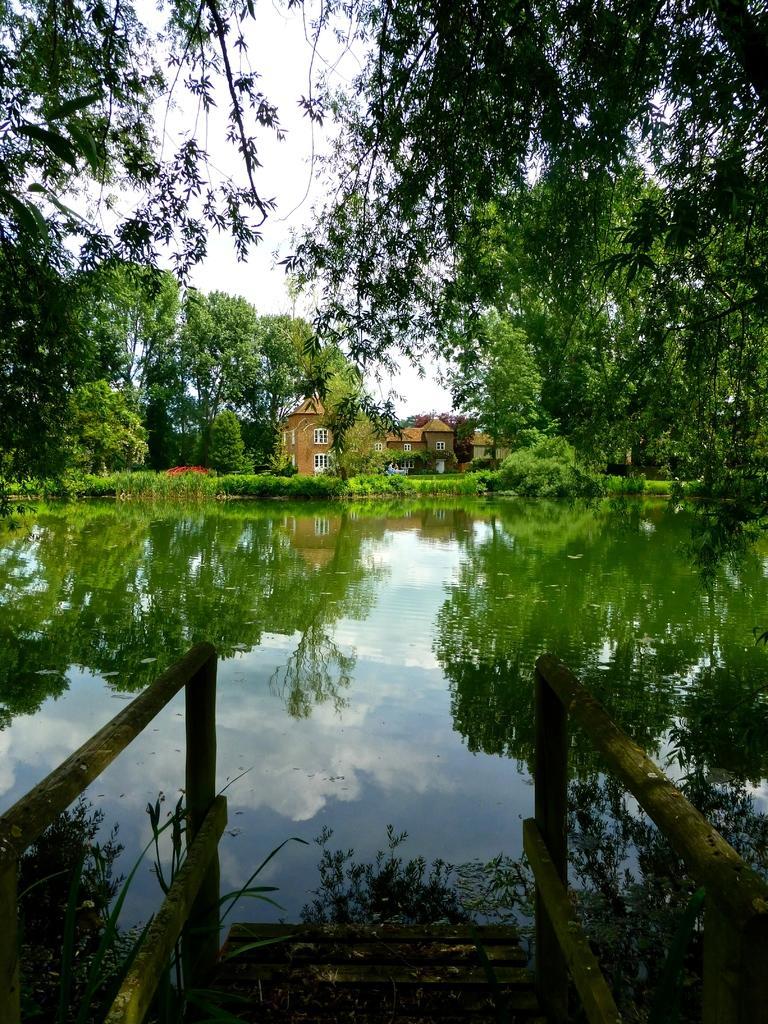Describe this image in one or two sentences. Bottom of the image there is water. In the middle of the image there is a building and there are some trees. Behind the trees there is sky. 